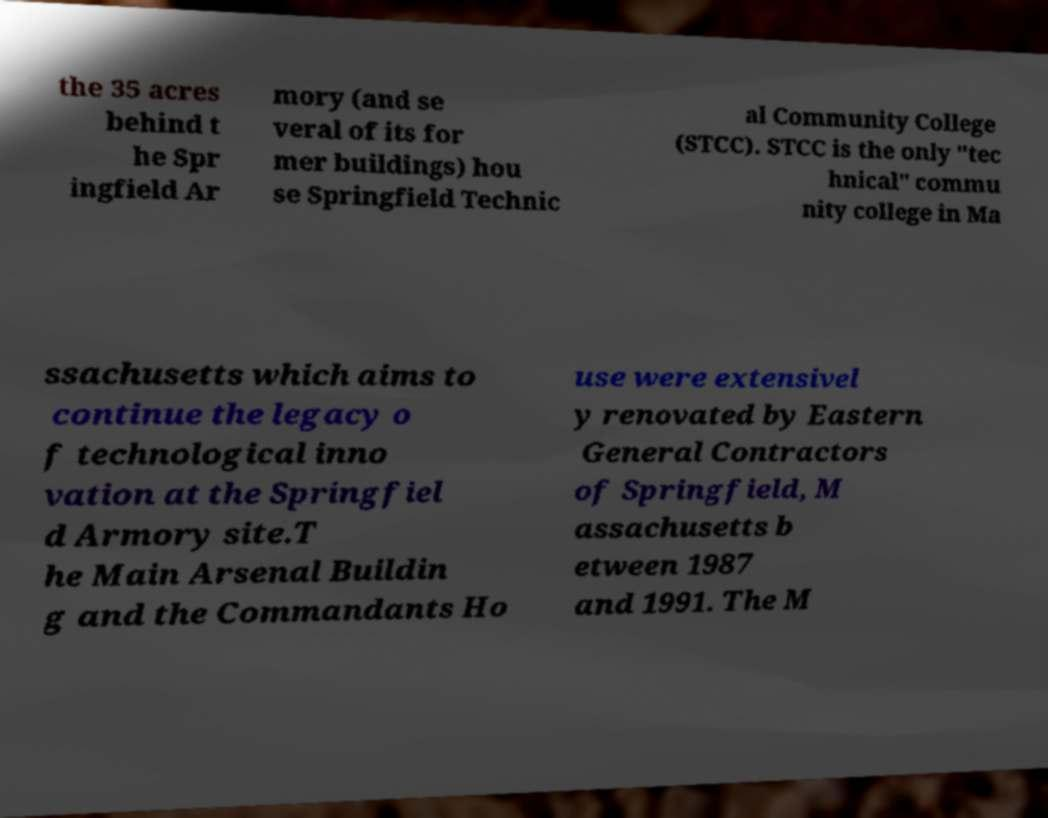Please read and relay the text visible in this image. What does it say? the 35 acres behind t he Spr ingfield Ar mory (and se veral of its for mer buildings) hou se Springfield Technic al Community College (STCC). STCC is the only "tec hnical" commu nity college in Ma ssachusetts which aims to continue the legacy o f technological inno vation at the Springfiel d Armory site.T he Main Arsenal Buildin g and the Commandants Ho use were extensivel y renovated by Eastern General Contractors of Springfield, M assachusetts b etween 1987 and 1991. The M 